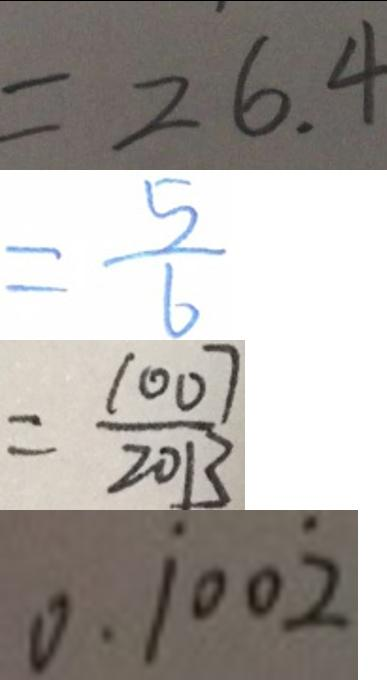<formula> <loc_0><loc_0><loc_500><loc_500>= 2 6 . 4 
 = \frac { 5 } { 6 } 
 = \frac { 1 0 0 7 } { 2 0 1 3 } 
 0 . \dot { 1 } 0 0 \dot { 2 }</formula> 